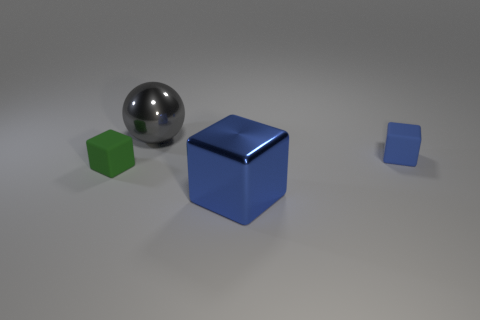Subtract all gray blocks. Subtract all brown cylinders. How many blocks are left? 3 Add 2 blue things. How many objects exist? 6 Subtract all spheres. How many objects are left? 3 Add 4 large blue objects. How many large blue objects are left? 5 Add 1 large balls. How many large balls exist? 2 Subtract 0 cyan cylinders. How many objects are left? 4 Subtract all brown metal balls. Subtract all tiny rubber objects. How many objects are left? 2 